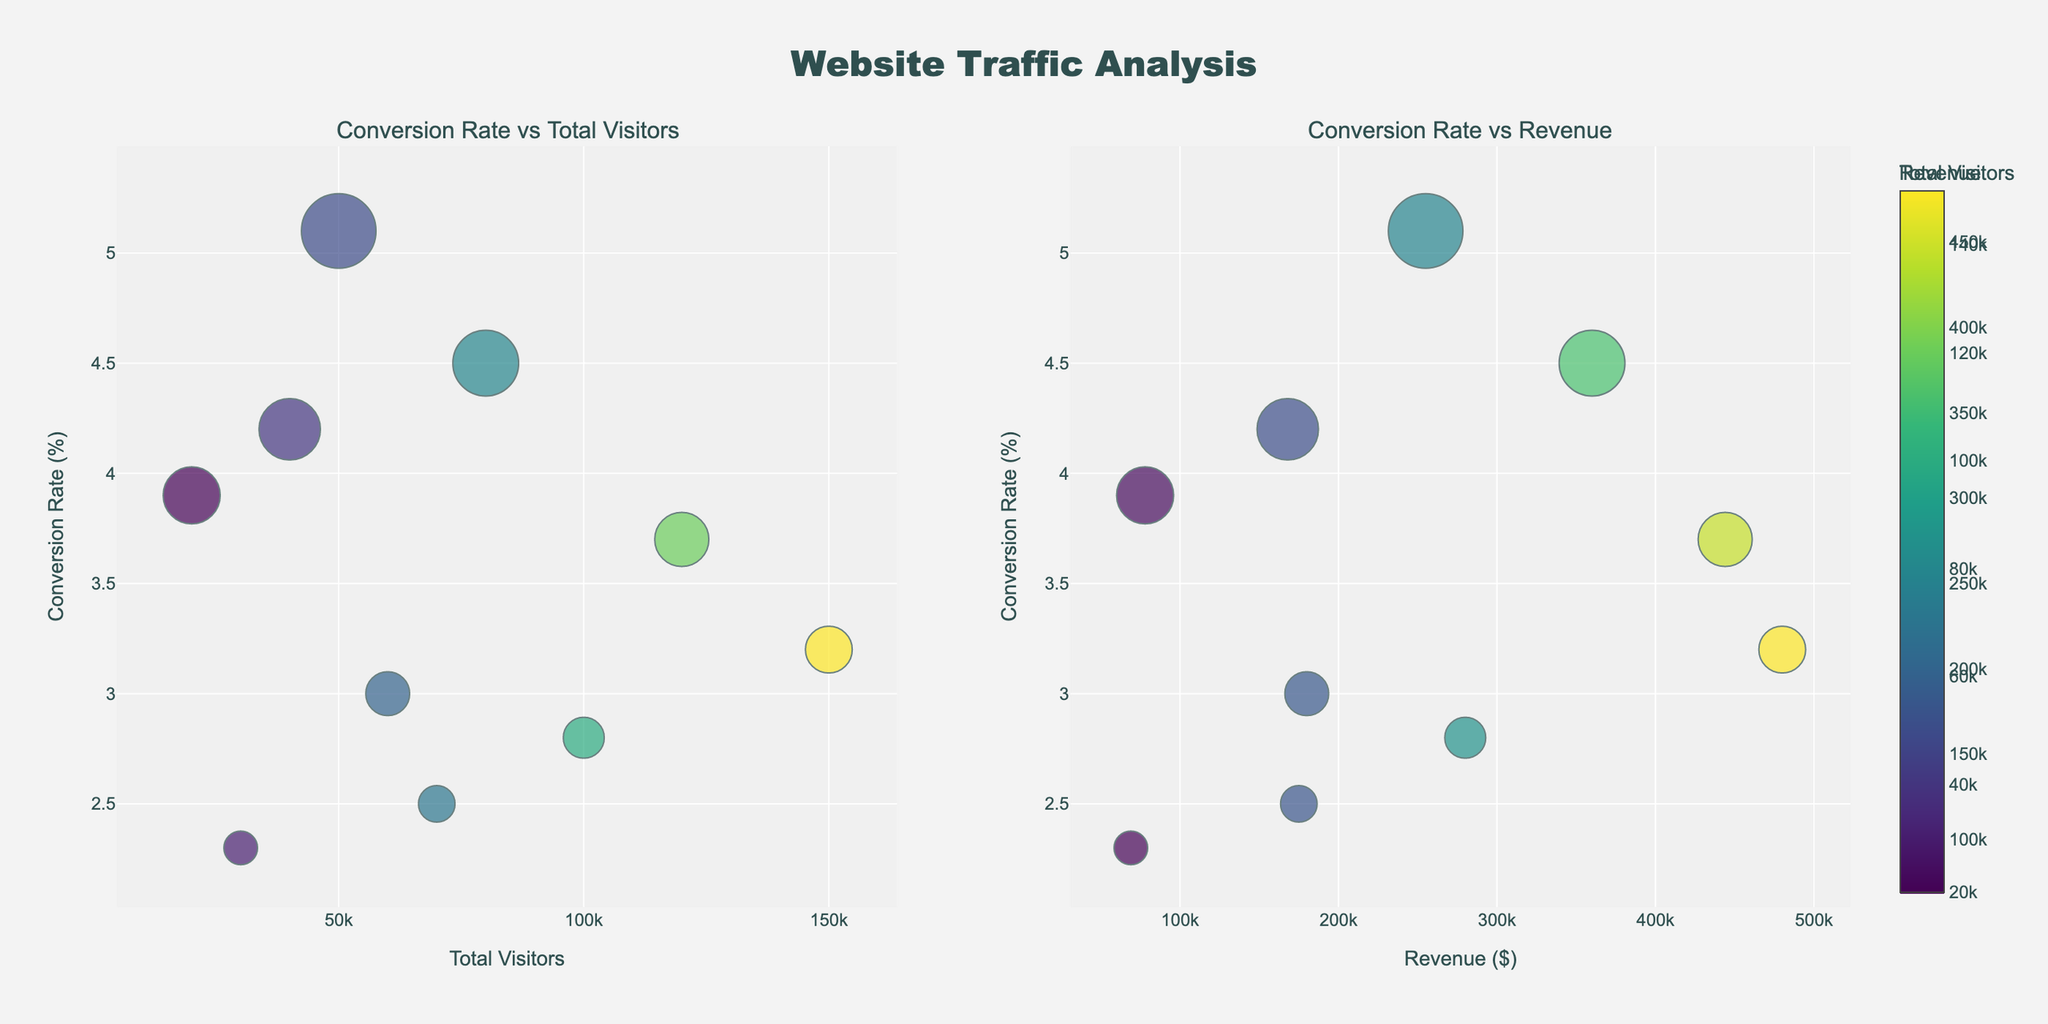what is the title of the figure? The title of the figure is displayed at the top center of the subplot. It states "Website Traffic Analysis".
Answer: Website Traffic Analysis what does the color of the bubbles in the left subplot represent? The color of the bubbles in the left subplot represents the 'Total Visitors' for each traffic source. The colorbar next to the subplot shows the gradient from low to high visitor numbers.
Answer: Total Visitors How many traffic sources have a conversion rate higher than 4%? There are three data points in the left subplot with a y-value (Conversion Rate) higher than 4%. These sources are Paid Search, Email Marketing, and Affiliate Marketing.
Answer: 3 which traffic source has the highest revenue? By observing the right subplot, the bubble with the highest x-value (Revenue) belongs to 'Organic Search' with a revenue of $480,000.
Answer: Organic Search Order the traffic sources by their conversion rates from highest to lowest. To answer this, we look at the y-values (Conversion Rate) on either subplot and sort them. The order from highest to lowest conversion rates is: Email Marketing, Paid Search, Affiliate Marketing, Influencer Partnerships, Direct Traffic, Organic Search, Referral, Social Media, Display Ads, Video Platforms.
Answer: Email Marketing, Paid Search, Affiliate Marketing, Influencer Partnerships, Direct Traffic, Organic Search, Referral, Social Media, Display Ads, Video Platforms What is the combined revenue of sources with at least 4.5% conversion rate? The sources with at least 4.5% conversion rate are Paid Search and Email Marketing. Their revenues are $360,000 and $255,000 respectively. The combined revenue is $360,000 + $255,000 = $615,000.
Answer: 615,000 which traffic source has the smallest bubble in the left subplot? The smallest bubble size is determined by the conversion rate. Video Platforms, with the lowest conversion rate of 2.3%, has the smallest bubble in the left subplot.
Answer: Video Platforms which traffic source has the highest total visitors, and what is its conversion rate? By comparing the x-values in the left subplot, 'Organic Search' has the highest total visitors with 150,000. Its conversion rate is 3.2%, shown as its y-value.
Answer: Organic Search, 3.2% Do traffic sources with higher total visitors always correspond with higher revenue? By comparing the bubble positions in both subplots, we can see that higher total visitors don't consistently lead to higher revenue. For example, 'Organic Search' has the most visitors but not the highest single conversion rate, showing variability in corresponding revenue.
Answer: No 